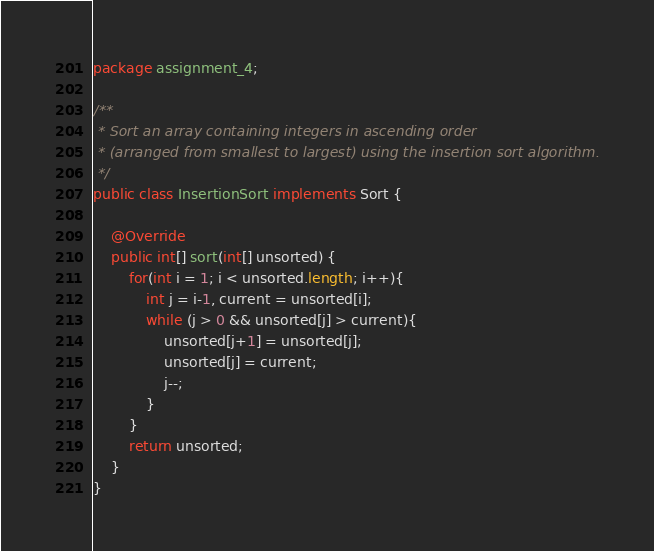Convert code to text. <code><loc_0><loc_0><loc_500><loc_500><_Java_>package assignment_4;

/**
 * Sort an array containing integers in ascending order
 * (arranged from smallest to largest) using the insertion sort algorithm.
 */
public class InsertionSort implements Sort {

	@Override
	public int[] sort(int[] unsorted) {
		for(int i = 1; i < unsorted.length; i++){
			int j = i-1, current = unsorted[i];
			while (j > 0 && unsorted[j] > current){
				unsorted[j+1] = unsorted[j];
				unsorted[j] = current;
				j--;
			}
		}
		return unsorted;
	}	
}</code> 